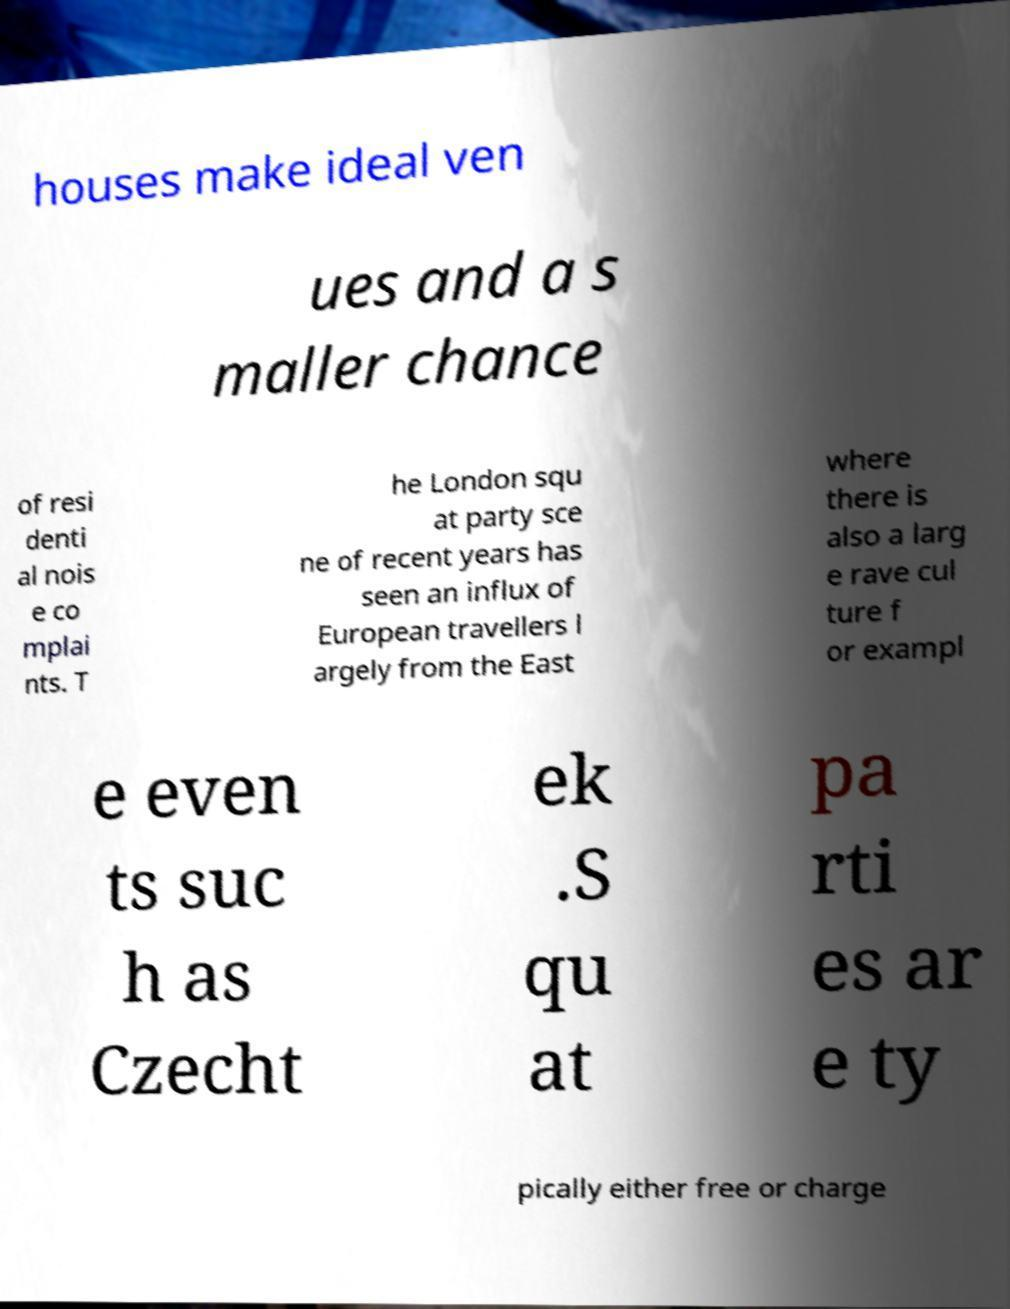Could you assist in decoding the text presented in this image and type it out clearly? houses make ideal ven ues and a s maller chance of resi denti al nois e co mplai nts. T he London squ at party sce ne of recent years has seen an influx of European travellers l argely from the East where there is also a larg e rave cul ture f or exampl e even ts suc h as Czecht ek .S qu at pa rti es ar e ty pically either free or charge 